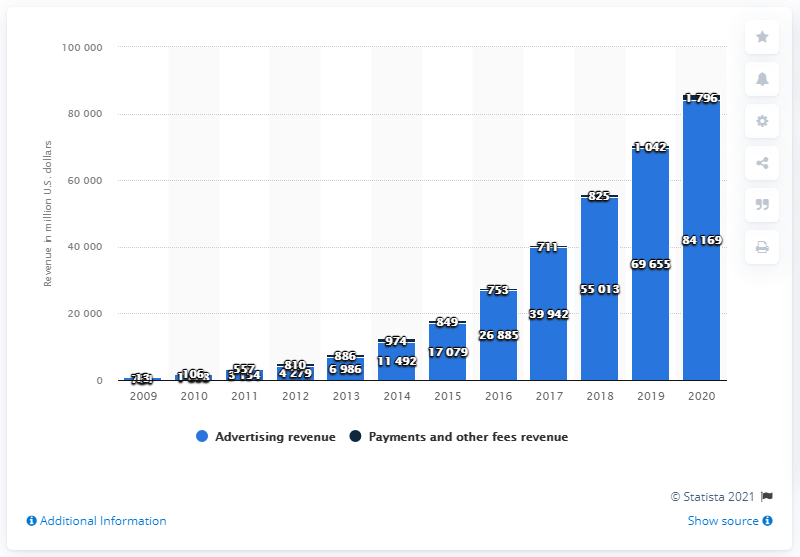Identify some key points in this picture. In 2020, Facebook's advertising revenue was approximately 84,169. In 2019, Facebook generated a total of $69.655 billion in advertising revenue. 